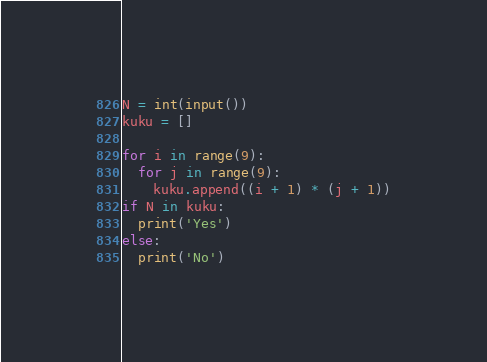Convert code to text. <code><loc_0><loc_0><loc_500><loc_500><_Python_>N = int(input())
kuku = []

for i in range(9):
  for j in range(9):
    kuku.append((i + 1) * (j + 1))
if N in kuku:
  print('Yes')
else:
  print('No')</code> 